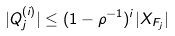Convert formula to latex. <formula><loc_0><loc_0><loc_500><loc_500>| Q _ { j } ^ { ( i ) } | \leq ( 1 - \rho ^ { - 1 } ) ^ { i } | X _ { F _ { j } } |</formula> 